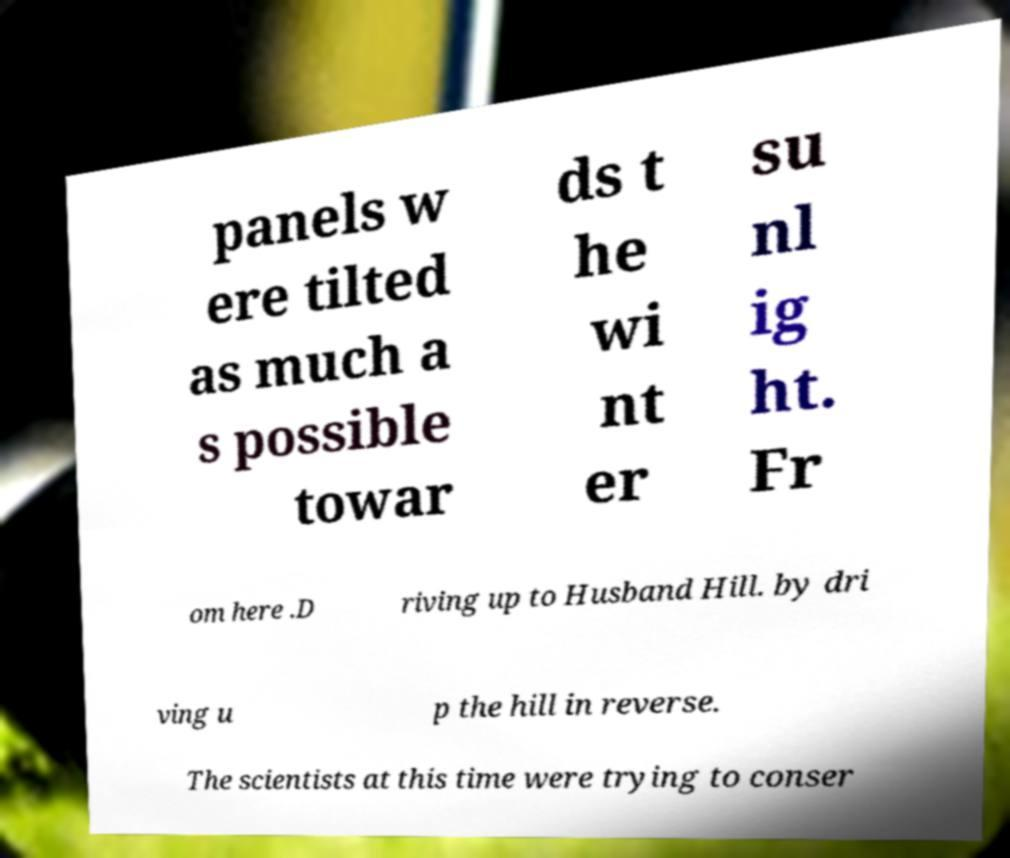There's text embedded in this image that I need extracted. Can you transcribe it verbatim? panels w ere tilted as much a s possible towar ds t he wi nt er su nl ig ht. Fr om here .D riving up to Husband Hill. by dri ving u p the hill in reverse. The scientists at this time were trying to conser 